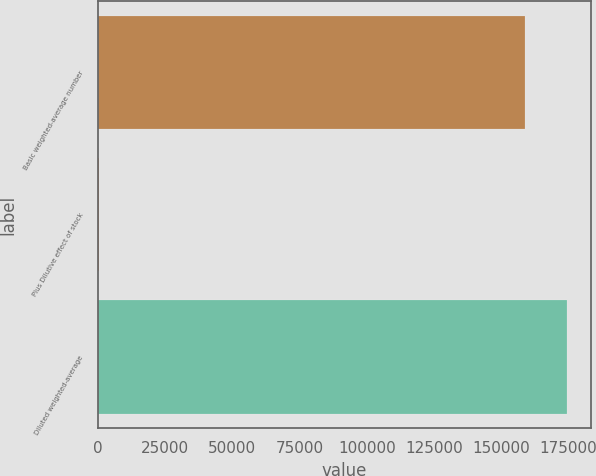Convert chart. <chart><loc_0><loc_0><loc_500><loc_500><bar_chart><fcel>Basic weighted-average number<fcel>Plus Dilutive effect of stock<fcel>Diluted weighted-average<nl><fcel>158672<fcel>599<fcel>174539<nl></chart> 